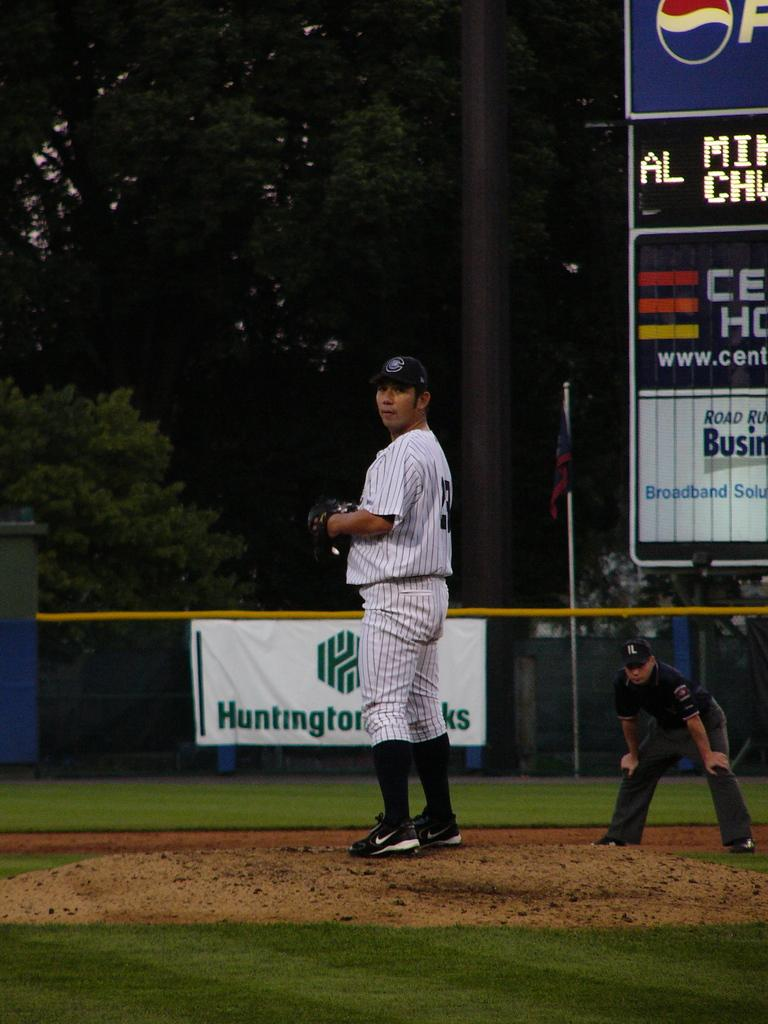<image>
Provide a brief description of the given image. An ad for Huntington Banks can be seen behind a baseball player. 